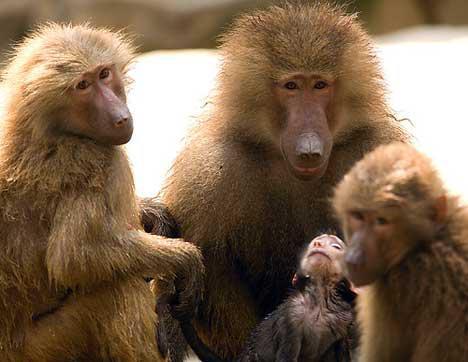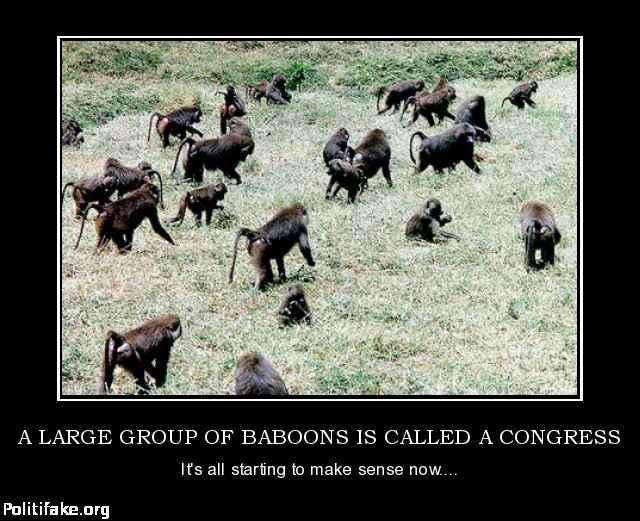The first image is the image on the left, the second image is the image on the right. Considering the images on both sides, is "There are no more than two tan and brown baboons outside on grass and dirt." valid? Answer yes or no. No. 